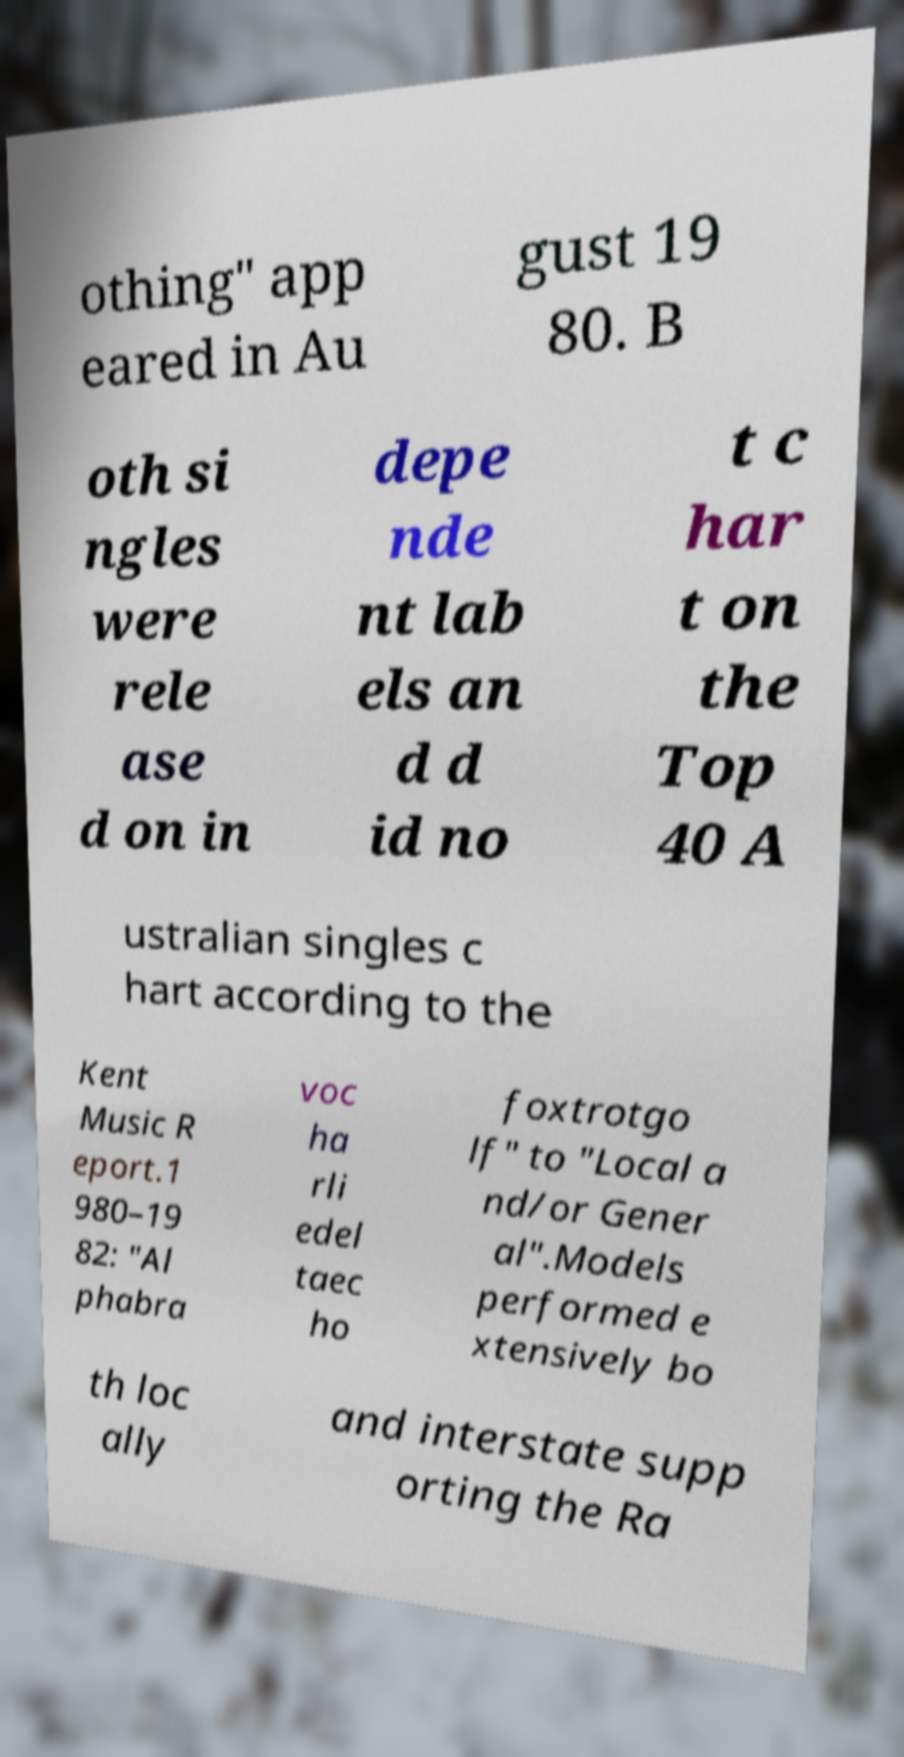I need the written content from this picture converted into text. Can you do that? othing" app eared in Au gust 19 80. B oth si ngles were rele ase d on in depe nde nt lab els an d d id no t c har t on the Top 40 A ustralian singles c hart according to the Kent Music R eport.1 980–19 82: "Al phabra voc ha rli edel taec ho foxtrotgo lf" to "Local a nd/or Gener al".Models performed e xtensively bo th loc ally and interstate supp orting the Ra 